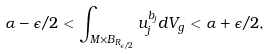Convert formula to latex. <formula><loc_0><loc_0><loc_500><loc_500>\alpha - \epsilon / 2 < \int _ { M \times B _ { R _ { \epsilon / 2 } } } u _ { j } ^ { b _ { j } } d V _ { g } < \alpha + \epsilon / 2 ,</formula> 